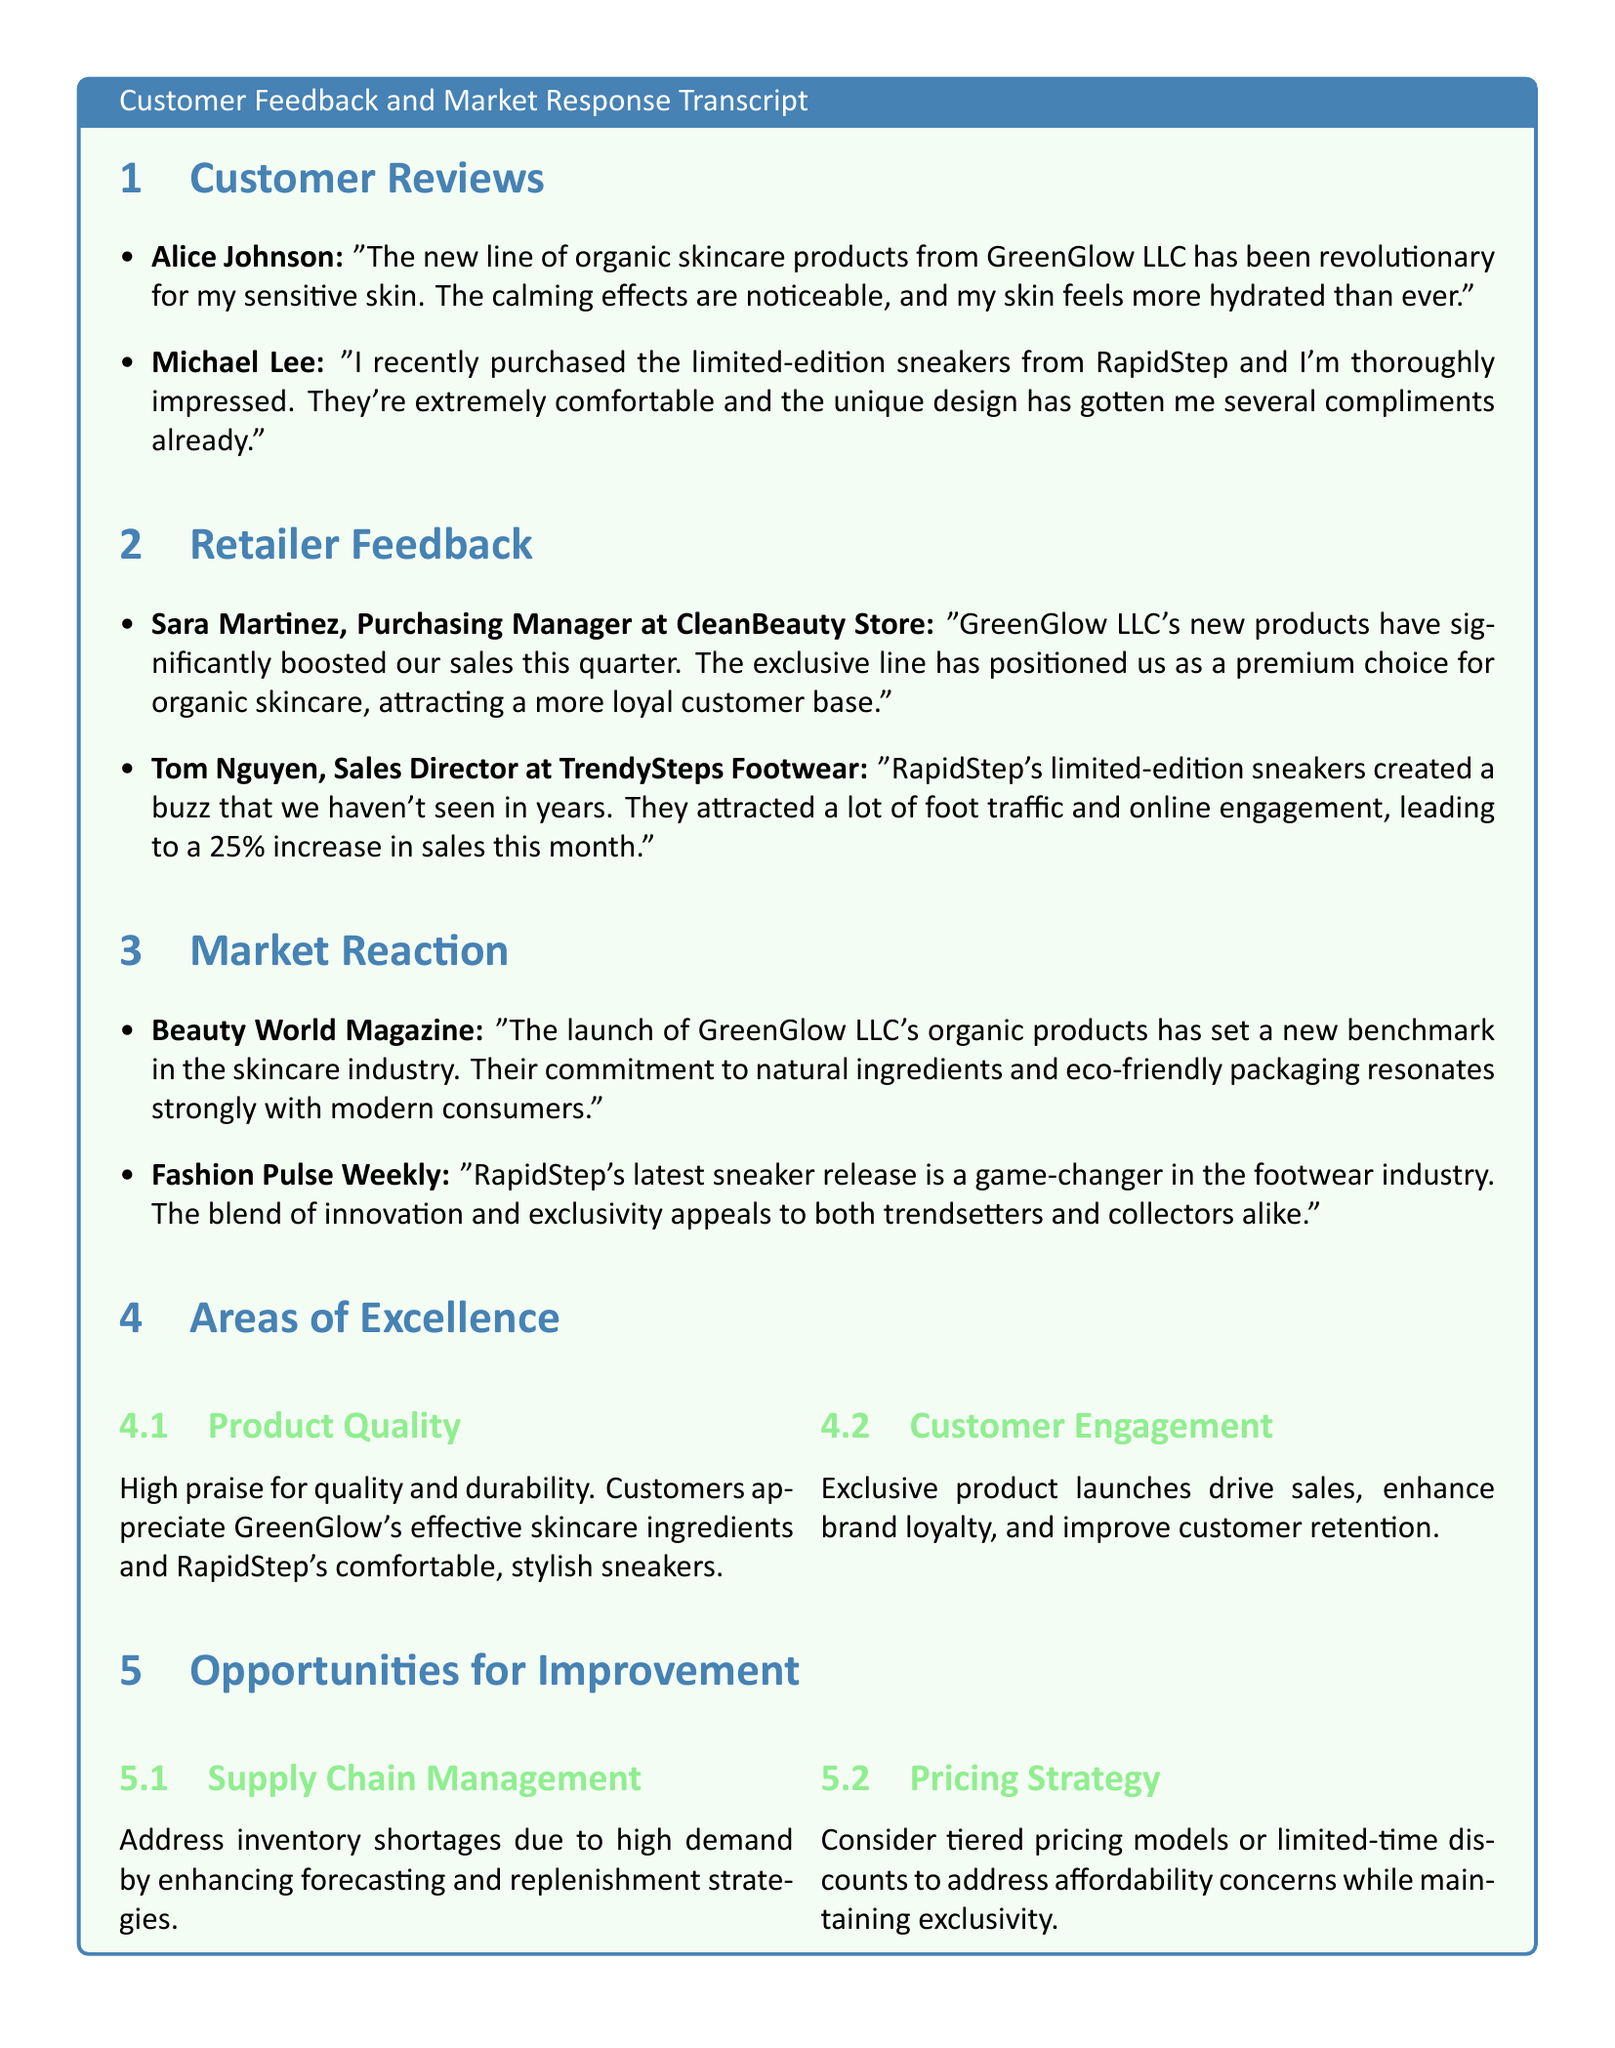What did Alice Johnson say about the new skincare products? Alice Johnson praised the skincare products from GreenGlow LLC for their revolutionary effects on her sensitive skin, mentioning noticeable calming effects and increased hydration.
Answer: "revolutionary for my sensitive skin. The calming effects are noticeable, and my skin feels more hydrated than ever." What percentage increase in sales did TrendySteps Footwear experience? Tom Nguyen reported that RapidStep's limited-edition sneakers led to a 25% increase in sales this month.
Answer: 25% Who is the Purchasing Manager at CleanBeauty Store? The document identifies Sara Martinez as the Purchasing Manager at CleanBeauty Store who provided feedback about GreenGlow LLC's products.
Answer: Sara Martinez What is one area of excellence highlighted in the document? The document notes high praise for product quality and customer engagement, which were considered areas of excellence.
Answer: Product Quality What is a suggested improvement for pricing strategy? The document suggests considering tiered pricing models or limited-time discounts to address affordability concerns while maintaining exclusivity.
Answer: tiered pricing models or limited-time discounts What was mentioned as a reason for high demand? Aging inventory management practices led to inventory shortages due to high demand for new products, which is mentioned as an area for improvement.
Answer: Supply Chain Management Which magazine noted the launch of GreenGlow LLC's organic products? Beauty World Magazine is recognized for commenting on the launch of GreenGlow LLC's organic products and their impact on the skincare industry.
Answer: Beauty World Magazine What unique aspect has been noted about the limited-edition sneakers? RapidStep's limited-edition sneakers are described as creating a buzz and appealing to both trendsetters and collectors.
Answer: exclusivity 